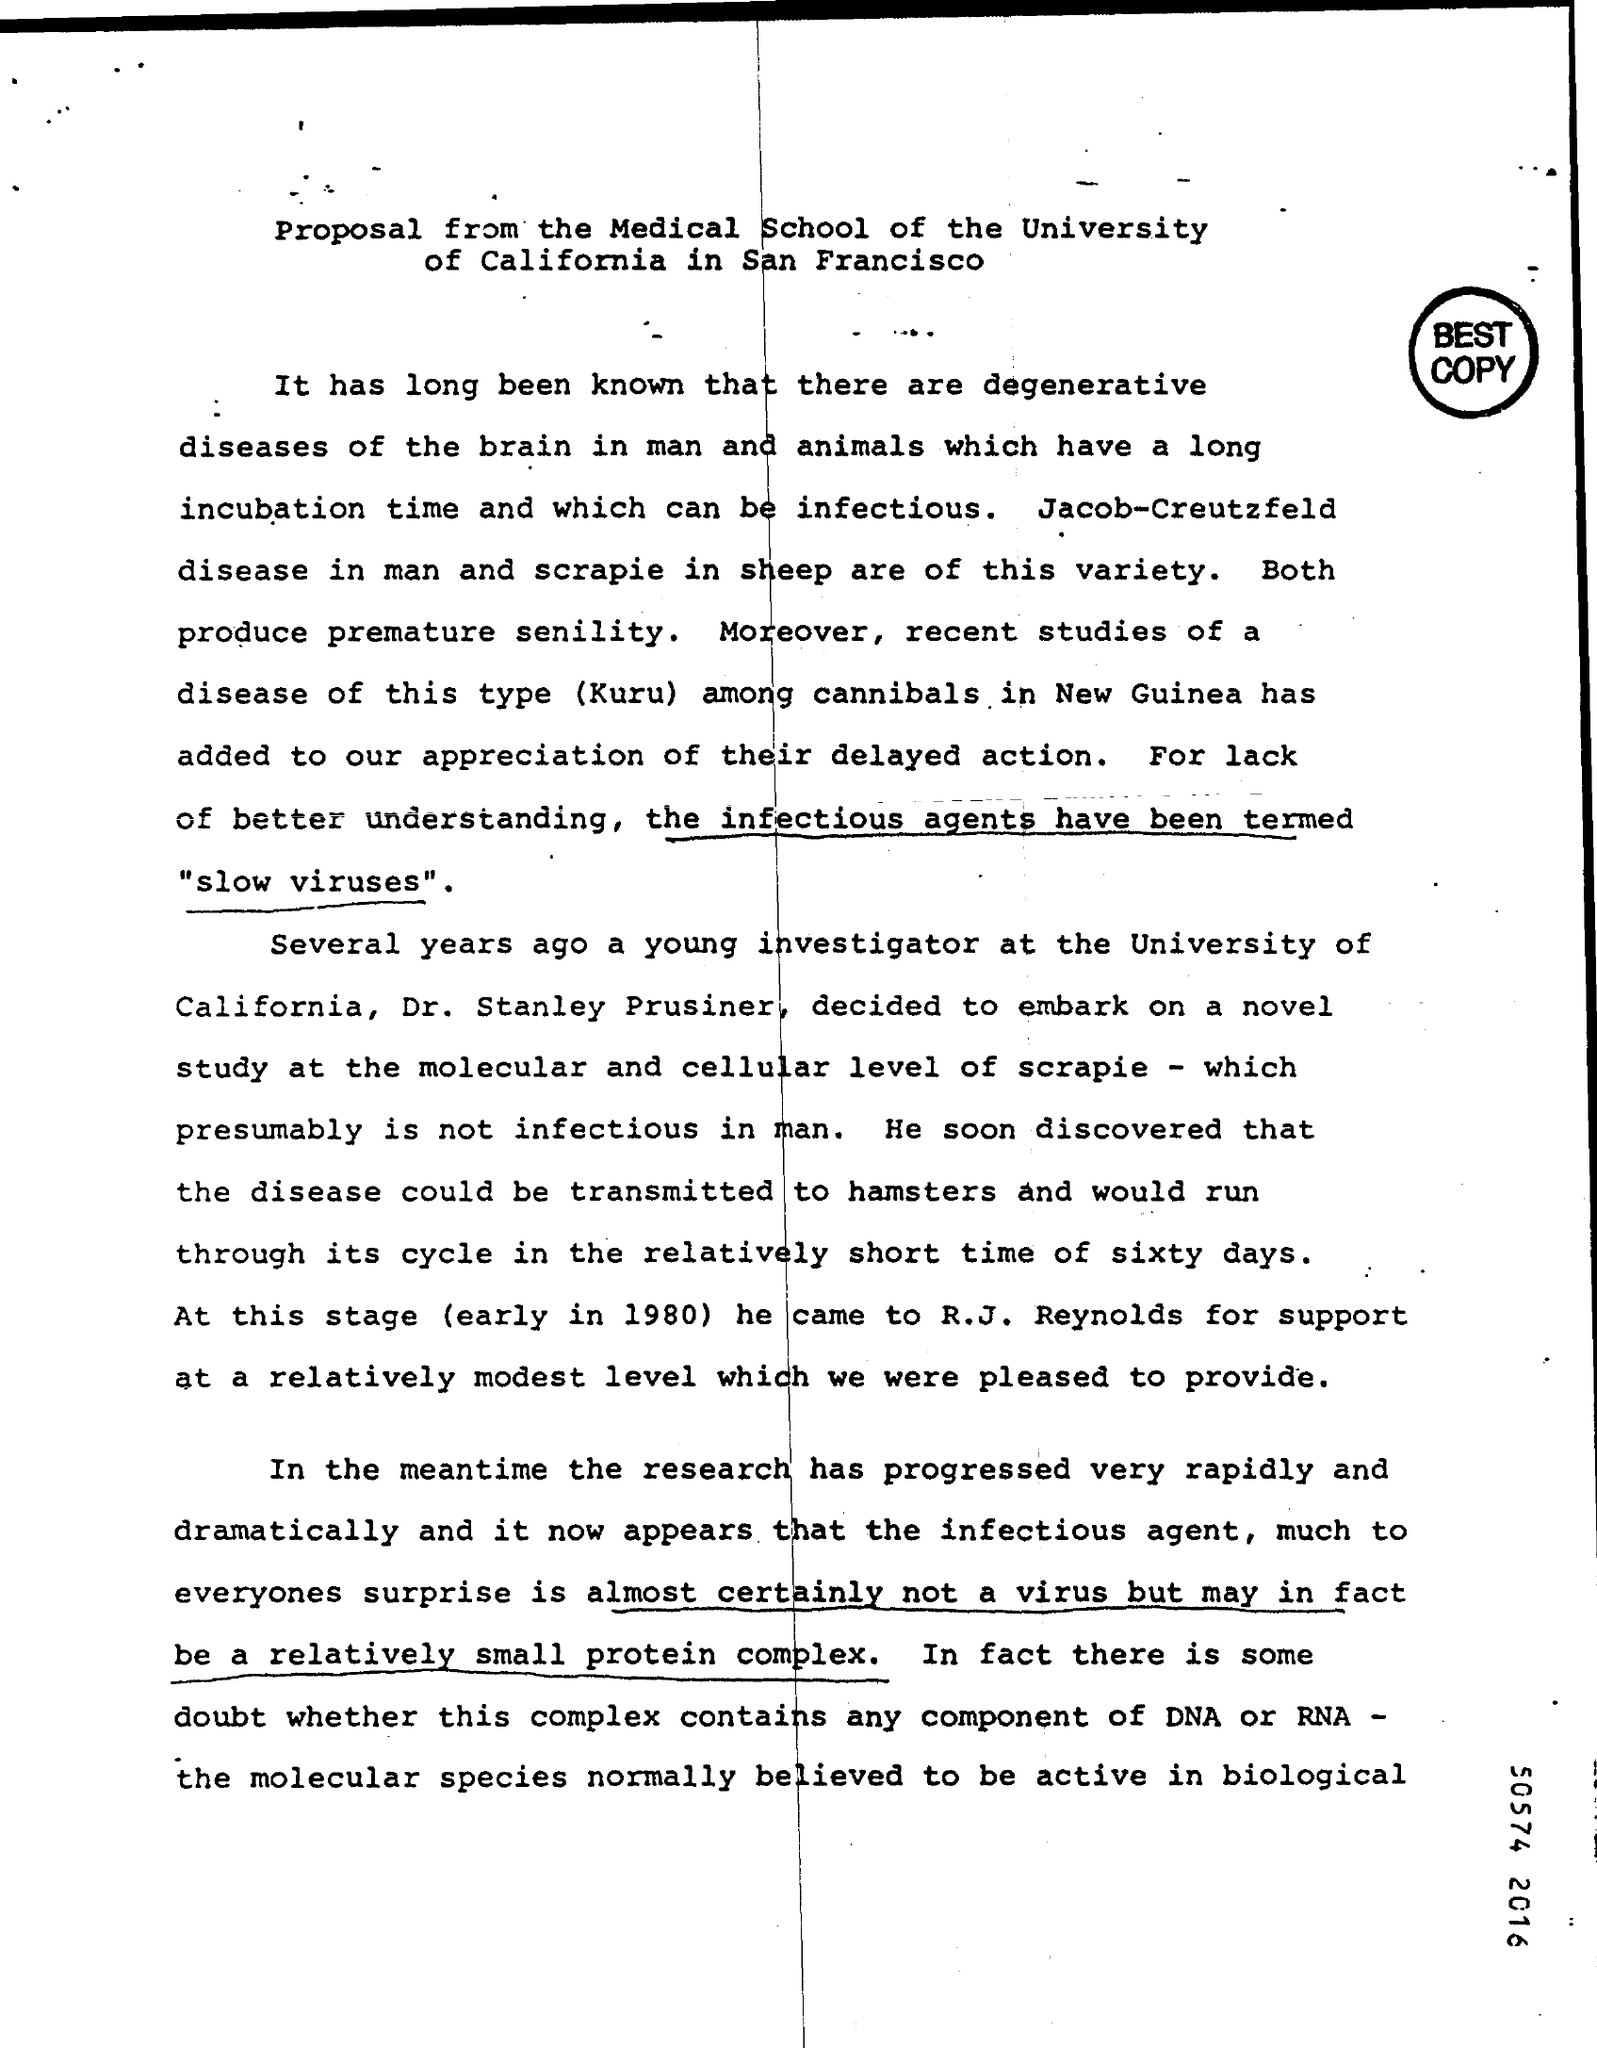What is the study type carried out among cannibals?
Offer a terse response. Kuru. What is time of life cycle when the disease is transmitted to hamsters?
Your response must be concise. Sixty days. What is the infectious agent now?
Your response must be concise. A relatively small protein complex. 